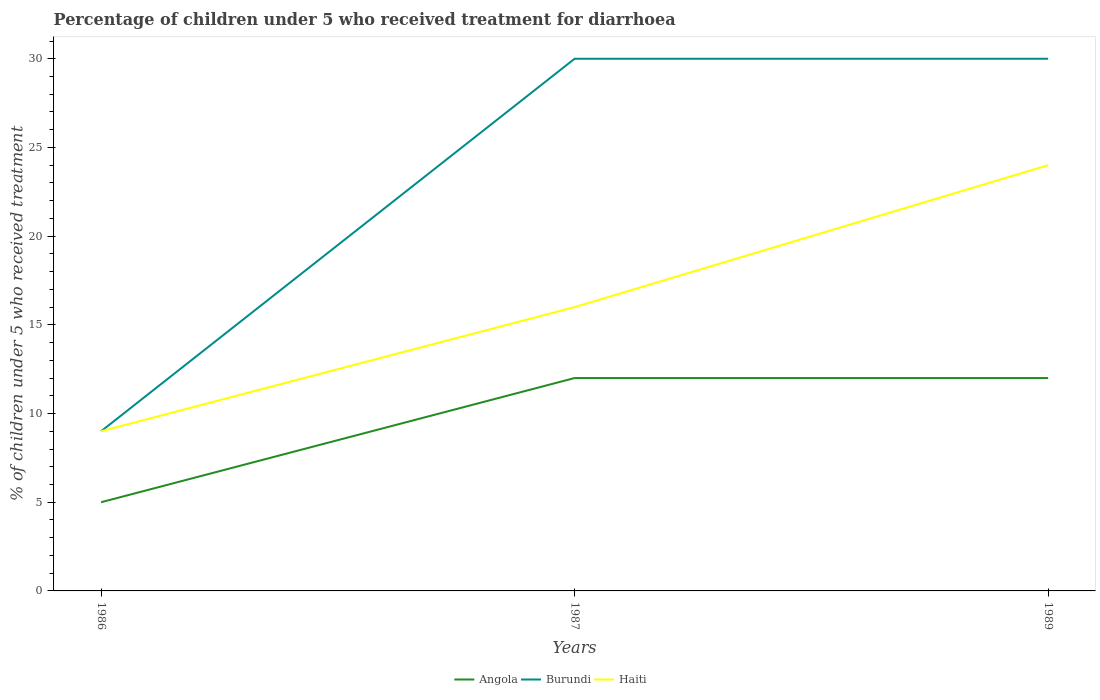Does the line corresponding to Burundi intersect with the line corresponding to Angola?
Provide a short and direct response. No. Is the number of lines equal to the number of legend labels?
Offer a very short reply. Yes. What is the difference between the highest and the second highest percentage of children who received treatment for diarrhoea  in Burundi?
Your answer should be very brief. 21. Is the percentage of children who received treatment for diarrhoea  in Burundi strictly greater than the percentage of children who received treatment for diarrhoea  in Haiti over the years?
Provide a short and direct response. No. How many lines are there?
Offer a very short reply. 3. How many years are there in the graph?
Your answer should be very brief. 3. Are the values on the major ticks of Y-axis written in scientific E-notation?
Keep it short and to the point. No. Does the graph contain grids?
Ensure brevity in your answer.  No. What is the title of the graph?
Offer a terse response. Percentage of children under 5 who received treatment for diarrhoea. What is the label or title of the Y-axis?
Give a very brief answer. % of children under 5 who received treatment. What is the % of children under 5 who received treatment of Angola in 1986?
Make the answer very short. 5. What is the % of children under 5 who received treatment in Burundi in 1986?
Offer a very short reply. 9. What is the % of children under 5 who received treatment of Angola in 1987?
Make the answer very short. 12. What is the % of children under 5 who received treatment of Haiti in 1987?
Provide a succinct answer. 16. What is the % of children under 5 who received treatment in Haiti in 1989?
Keep it short and to the point. 24. Across all years, what is the maximum % of children under 5 who received treatment of Angola?
Offer a terse response. 12. Across all years, what is the maximum % of children under 5 who received treatment in Burundi?
Give a very brief answer. 30. Across all years, what is the minimum % of children under 5 who received treatment in Burundi?
Offer a terse response. 9. Across all years, what is the minimum % of children under 5 who received treatment of Haiti?
Make the answer very short. 9. What is the difference between the % of children under 5 who received treatment of Angola in 1986 and that in 1987?
Make the answer very short. -7. What is the difference between the % of children under 5 who received treatment of Burundi in 1986 and that in 1987?
Ensure brevity in your answer.  -21. What is the difference between the % of children under 5 who received treatment of Burundi in 1986 and that in 1989?
Your response must be concise. -21. What is the difference between the % of children under 5 who received treatment in Burundi in 1987 and that in 1989?
Your answer should be compact. 0. What is the difference between the % of children under 5 who received treatment in Haiti in 1987 and that in 1989?
Provide a succinct answer. -8. What is the difference between the % of children under 5 who received treatment of Angola in 1986 and the % of children under 5 who received treatment of Burundi in 1987?
Provide a succinct answer. -25. What is the difference between the % of children under 5 who received treatment of Burundi in 1986 and the % of children under 5 who received treatment of Haiti in 1987?
Keep it short and to the point. -7. What is the difference between the % of children under 5 who received treatment in Angola in 1986 and the % of children under 5 who received treatment in Burundi in 1989?
Offer a very short reply. -25. What is the difference between the % of children under 5 who received treatment in Angola in 1986 and the % of children under 5 who received treatment in Haiti in 1989?
Offer a very short reply. -19. What is the difference between the % of children under 5 who received treatment of Burundi in 1986 and the % of children under 5 who received treatment of Haiti in 1989?
Your answer should be very brief. -15. What is the difference between the % of children under 5 who received treatment of Angola in 1987 and the % of children under 5 who received treatment of Burundi in 1989?
Offer a terse response. -18. What is the difference between the % of children under 5 who received treatment in Angola in 1987 and the % of children under 5 who received treatment in Haiti in 1989?
Provide a succinct answer. -12. What is the average % of children under 5 who received treatment in Angola per year?
Make the answer very short. 9.67. What is the average % of children under 5 who received treatment in Burundi per year?
Ensure brevity in your answer.  23. What is the average % of children under 5 who received treatment of Haiti per year?
Your answer should be compact. 16.33. In the year 1987, what is the difference between the % of children under 5 who received treatment in Angola and % of children under 5 who received treatment in Burundi?
Ensure brevity in your answer.  -18. In the year 1989, what is the difference between the % of children under 5 who received treatment in Angola and % of children under 5 who received treatment in Burundi?
Provide a short and direct response. -18. In the year 1989, what is the difference between the % of children under 5 who received treatment of Angola and % of children under 5 who received treatment of Haiti?
Give a very brief answer. -12. In the year 1989, what is the difference between the % of children under 5 who received treatment in Burundi and % of children under 5 who received treatment in Haiti?
Provide a short and direct response. 6. What is the ratio of the % of children under 5 who received treatment in Angola in 1986 to that in 1987?
Offer a terse response. 0.42. What is the ratio of the % of children under 5 who received treatment in Burundi in 1986 to that in 1987?
Your answer should be very brief. 0.3. What is the ratio of the % of children under 5 who received treatment of Haiti in 1986 to that in 1987?
Keep it short and to the point. 0.56. What is the ratio of the % of children under 5 who received treatment of Angola in 1986 to that in 1989?
Your answer should be compact. 0.42. What is the ratio of the % of children under 5 who received treatment in Burundi in 1986 to that in 1989?
Provide a short and direct response. 0.3. What is the ratio of the % of children under 5 who received treatment of Haiti in 1986 to that in 1989?
Give a very brief answer. 0.38. What is the difference between the highest and the lowest % of children under 5 who received treatment in Angola?
Your response must be concise. 7. What is the difference between the highest and the lowest % of children under 5 who received treatment of Burundi?
Make the answer very short. 21. What is the difference between the highest and the lowest % of children under 5 who received treatment of Haiti?
Keep it short and to the point. 15. 